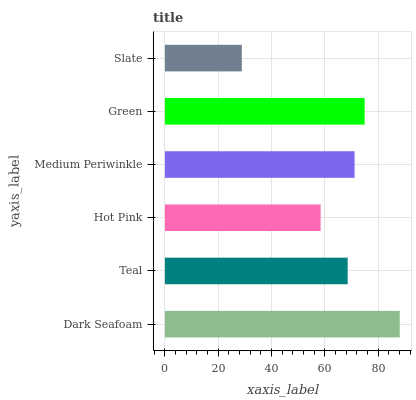Is Slate the minimum?
Answer yes or no. Yes. Is Dark Seafoam the maximum?
Answer yes or no. Yes. Is Teal the minimum?
Answer yes or no. No. Is Teal the maximum?
Answer yes or no. No. Is Dark Seafoam greater than Teal?
Answer yes or no. Yes. Is Teal less than Dark Seafoam?
Answer yes or no. Yes. Is Teal greater than Dark Seafoam?
Answer yes or no. No. Is Dark Seafoam less than Teal?
Answer yes or no. No. Is Medium Periwinkle the high median?
Answer yes or no. Yes. Is Teal the low median?
Answer yes or no. Yes. Is Teal the high median?
Answer yes or no. No. Is Dark Seafoam the low median?
Answer yes or no. No. 